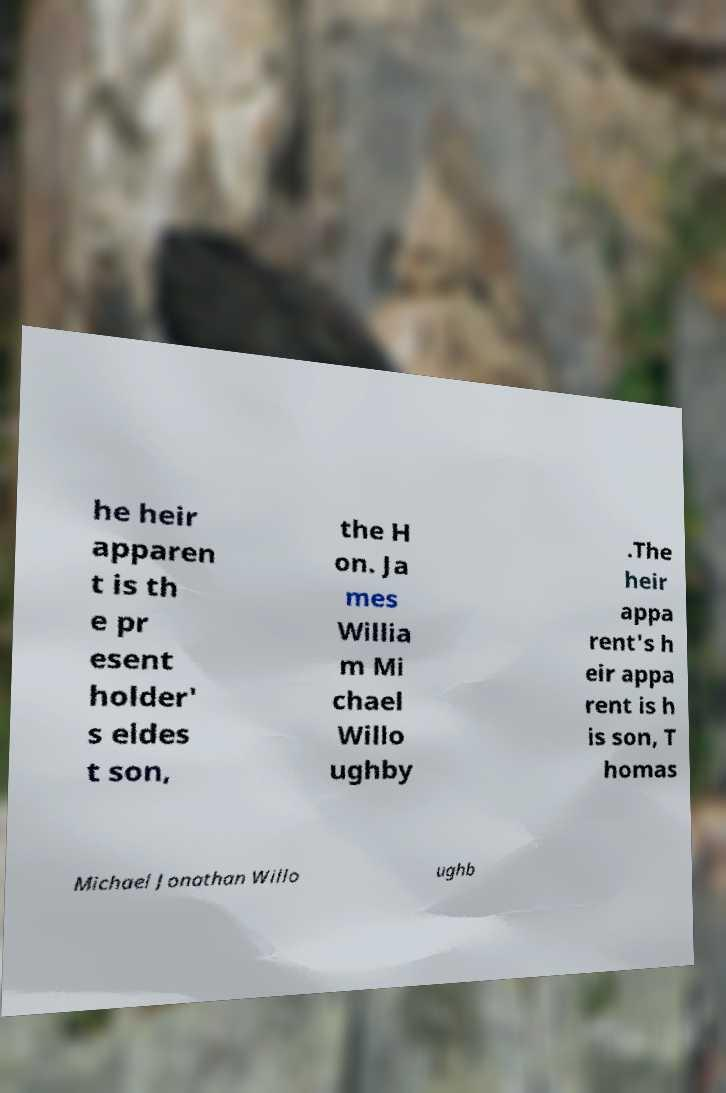For documentation purposes, I need the text within this image transcribed. Could you provide that? he heir apparen t is th e pr esent holder' s eldes t son, the H on. Ja mes Willia m Mi chael Willo ughby .The heir appa rent's h eir appa rent is h is son, T homas Michael Jonathan Willo ughb 